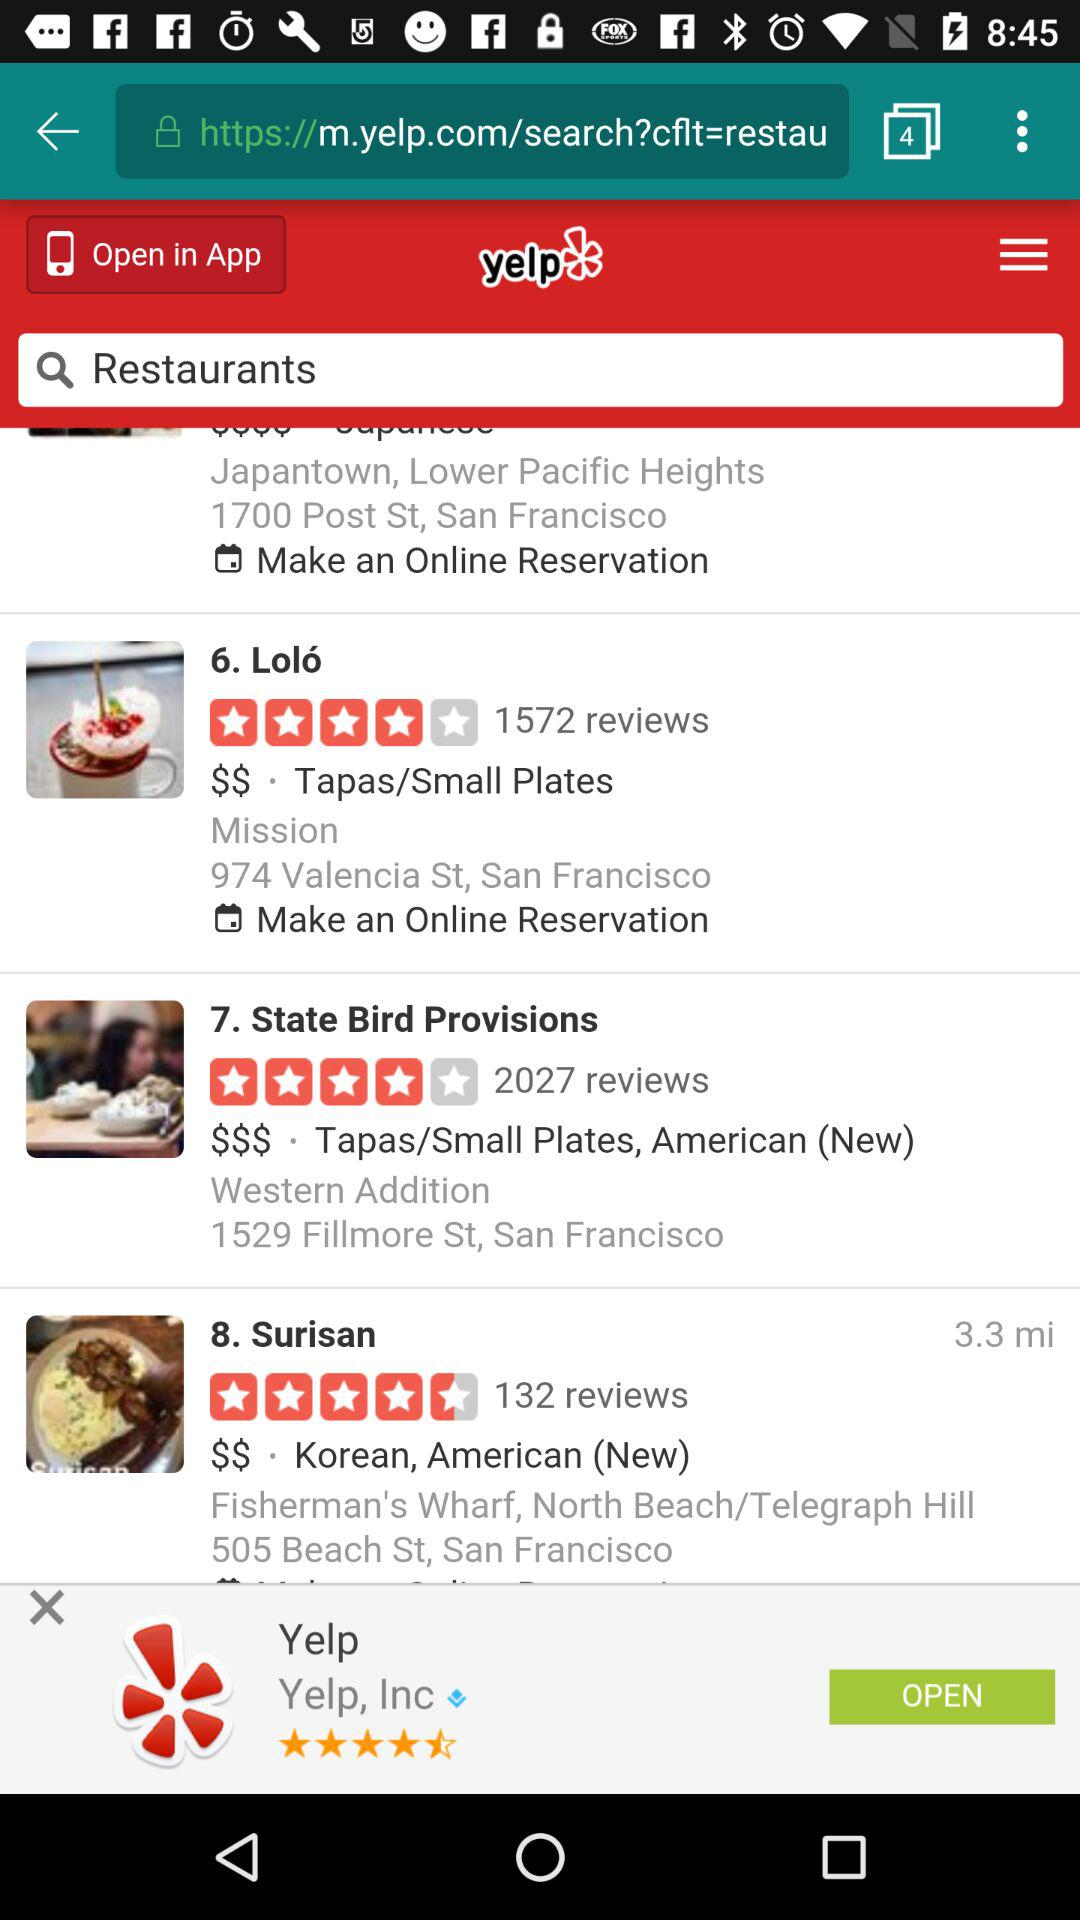What is the total number of reviews for State Bird Provisions? The total number of reviews is 2027. 